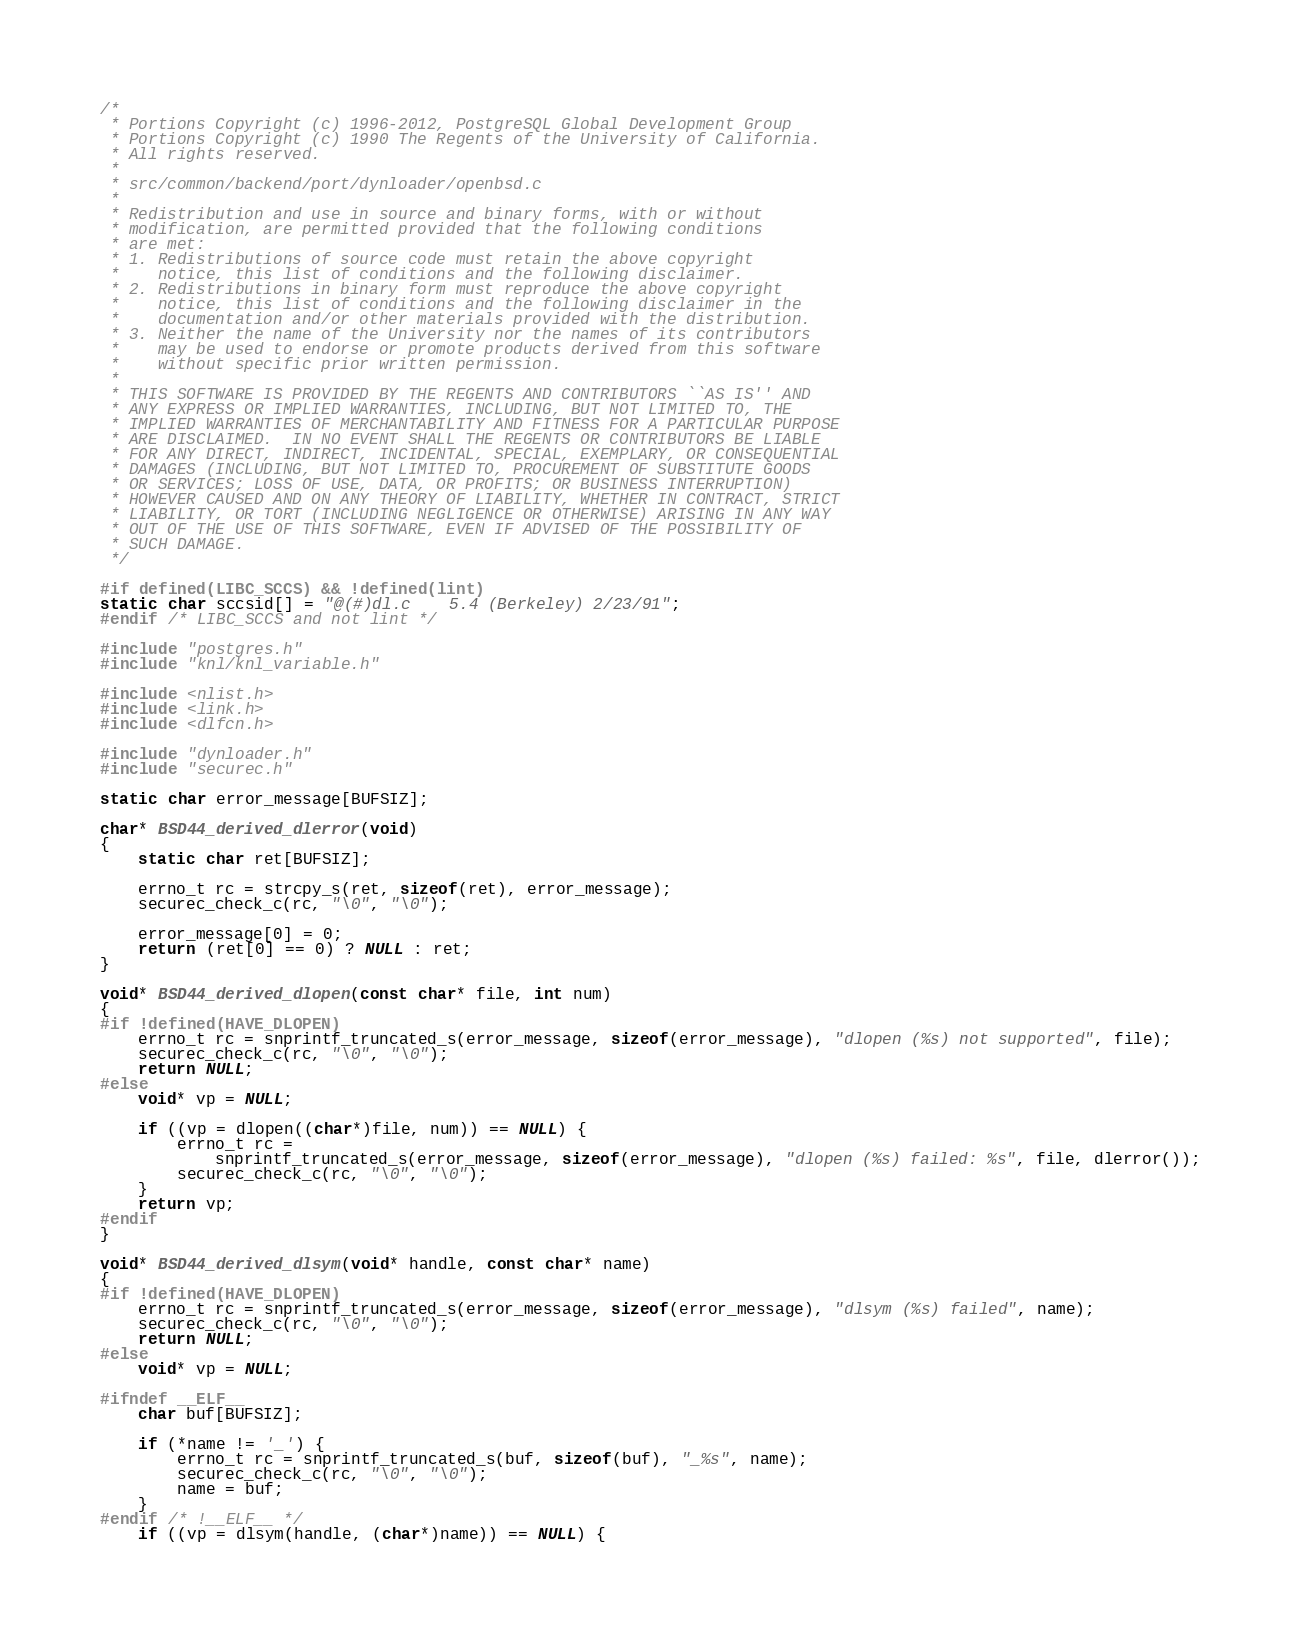Convert code to text. <code><loc_0><loc_0><loc_500><loc_500><_C++_>/*
 * Portions Copyright (c) 1996-2012, PostgreSQL Global Development Group
 * Portions Copyright (c) 1990 The Regents of the University of California.
 * All rights reserved.
 *
 * src/common/backend/port/dynloader/openbsd.c
 *
 * Redistribution and use in source and binary forms, with or without
 * modification, are permitted provided that the following conditions
 * are met:
 * 1. Redistributions of source code must retain the above copyright
 *	  notice, this list of conditions and the following disclaimer.
 * 2. Redistributions in binary form must reproduce the above copyright
 *	  notice, this list of conditions and the following disclaimer in the
 *	  documentation and/or other materials provided with the distribution.
 * 3. Neither the name of the University nor the names of its contributors
 *	  may be used to endorse or promote products derived from this software
 *	  without specific prior written permission.
 *
 * THIS SOFTWARE IS PROVIDED BY THE REGENTS AND CONTRIBUTORS ``AS IS'' AND
 * ANY EXPRESS OR IMPLIED WARRANTIES, INCLUDING, BUT NOT LIMITED TO, THE
 * IMPLIED WARRANTIES OF MERCHANTABILITY AND FITNESS FOR A PARTICULAR PURPOSE
 * ARE DISCLAIMED.	IN NO EVENT SHALL THE REGENTS OR CONTRIBUTORS BE LIABLE
 * FOR ANY DIRECT, INDIRECT, INCIDENTAL, SPECIAL, EXEMPLARY, OR CONSEQUENTIAL
 * DAMAGES (INCLUDING, BUT NOT LIMITED TO, PROCUREMENT OF SUBSTITUTE GOODS
 * OR SERVICES; LOSS OF USE, DATA, OR PROFITS; OR BUSINESS INTERRUPTION)
 * HOWEVER CAUSED AND ON ANY THEORY OF LIABILITY, WHETHER IN CONTRACT, STRICT
 * LIABILITY, OR TORT (INCLUDING NEGLIGENCE OR OTHERWISE) ARISING IN ANY WAY
 * OUT OF THE USE OF THIS SOFTWARE, EVEN IF ADVISED OF THE POSSIBILITY OF
 * SUCH DAMAGE.
 */

#if defined(LIBC_SCCS) && !defined(lint)
static char sccsid[] = "@(#)dl.c	5.4 (Berkeley) 2/23/91";
#endif /* LIBC_SCCS and not lint */

#include "postgres.h"
#include "knl/knl_variable.h"

#include <nlist.h>
#include <link.h>
#include <dlfcn.h>

#include "dynloader.h"
#include "securec.h"

static char error_message[BUFSIZ];

char* BSD44_derived_dlerror(void)
{
    static char ret[BUFSIZ];

    errno_t rc = strcpy_s(ret, sizeof(ret), error_message);
    securec_check_c(rc, "\0", "\0");

    error_message[0] = 0;
    return (ret[0] == 0) ? NULL : ret;
}

void* BSD44_derived_dlopen(const char* file, int num)
{
#if !defined(HAVE_DLOPEN)
    errno_t rc = snprintf_truncated_s(error_message, sizeof(error_message), "dlopen (%s) not supported", file);
    securec_check_c(rc, "\0", "\0");
    return NULL;
#else
    void* vp = NULL;

    if ((vp = dlopen((char*)file, num)) == NULL) {
        errno_t rc =
            snprintf_truncated_s(error_message, sizeof(error_message), "dlopen (%s) failed: %s", file, dlerror());
        securec_check_c(rc, "\0", "\0");
    }
    return vp;
#endif
}

void* BSD44_derived_dlsym(void* handle, const char* name)
{
#if !defined(HAVE_DLOPEN)
    errno_t rc = snprintf_truncated_s(error_message, sizeof(error_message), "dlsym (%s) failed", name);
    securec_check_c(rc, "\0", "\0");
    return NULL;
#else
    void* vp = NULL;

#ifndef __ELF__
    char buf[BUFSIZ];

    if (*name != '_') {
        errno_t rc = snprintf_truncated_s(buf, sizeof(buf), "_%s", name);
        securec_check_c(rc, "\0", "\0");
        name = buf;
    }
#endif /* !__ELF__ */
    if ((vp = dlsym(handle, (char*)name)) == NULL) {</code> 